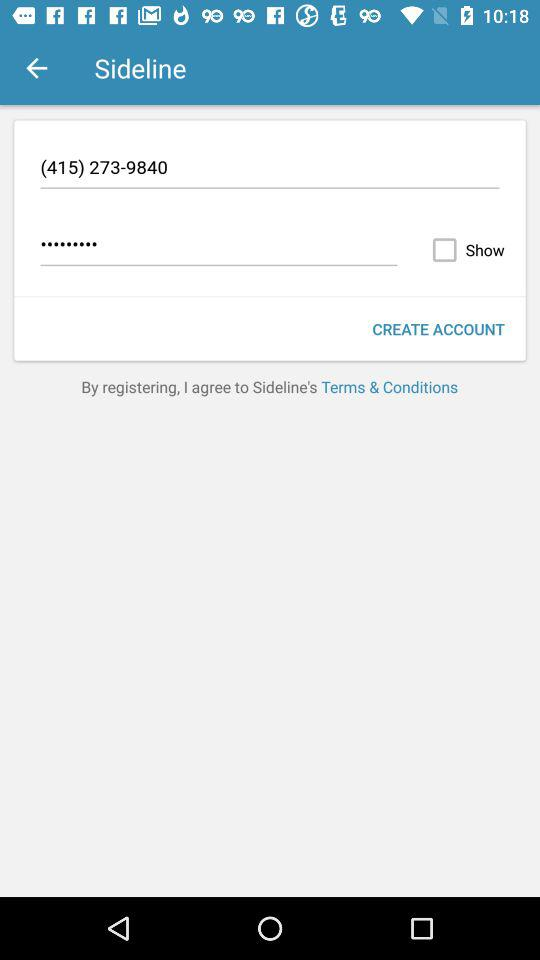How many characters are required to create a password?
When the provided information is insufficient, respond with <no answer>. <no answer> 